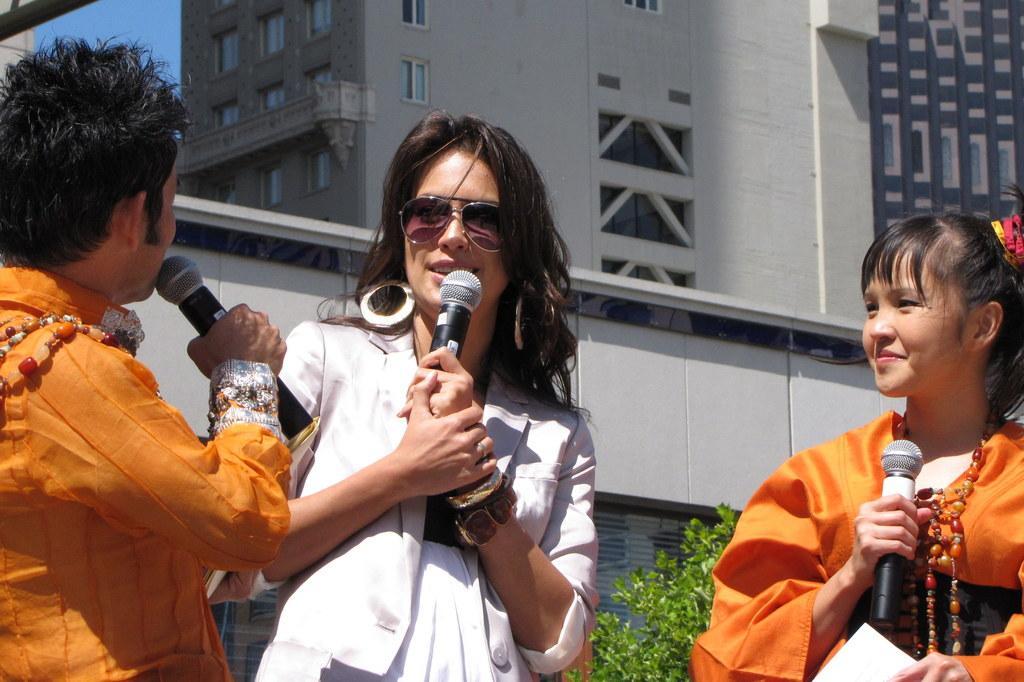Can you describe this image briefly? in this image In the middle there is a woman she is holding mic, her hair is short. On the right there is a woman she is staring at man. The three are holding mic. In the background there is building and plant. 